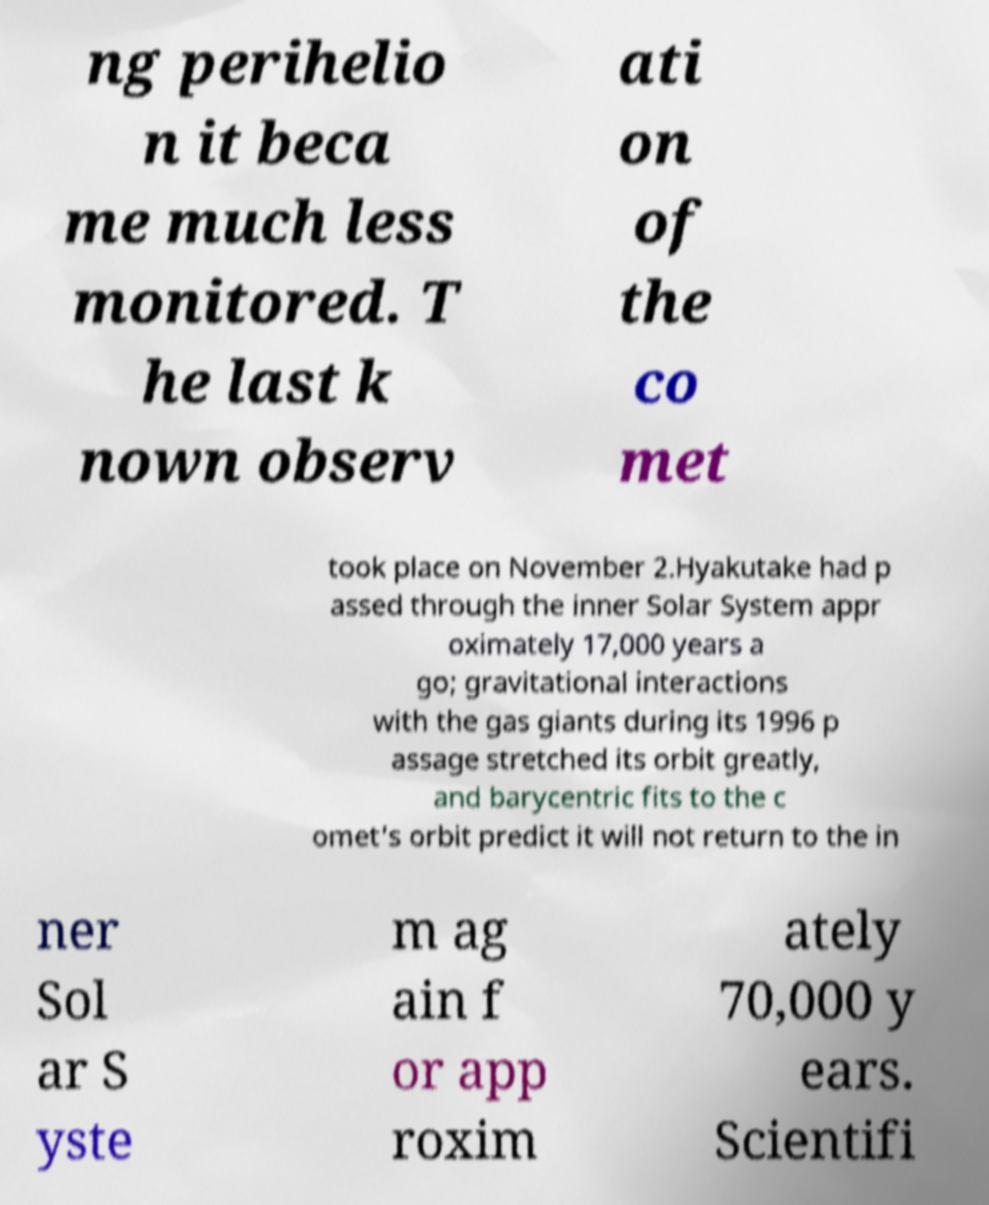Please identify and transcribe the text found in this image. ng perihelio n it beca me much less monitored. T he last k nown observ ati on of the co met took place on November 2.Hyakutake had p assed through the inner Solar System appr oximately 17,000 years a go; gravitational interactions with the gas giants during its 1996 p assage stretched its orbit greatly, and barycentric fits to the c omet's orbit predict it will not return to the in ner Sol ar S yste m ag ain f or app roxim ately 70,000 y ears. Scientifi 